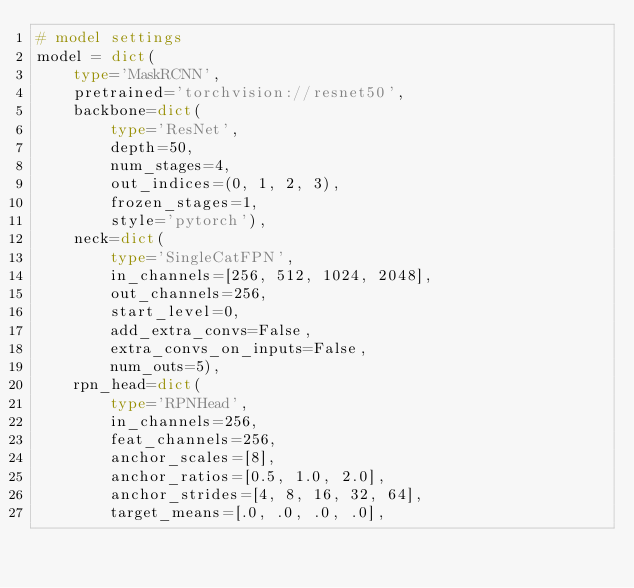<code> <loc_0><loc_0><loc_500><loc_500><_Python_># model settings
model = dict(
    type='MaskRCNN',
    pretrained='torchvision://resnet50',
    backbone=dict(
        type='ResNet',
        depth=50,
        num_stages=4,
        out_indices=(0, 1, 2, 3),
        frozen_stages=1,
        style='pytorch'),
    neck=dict(
        type='SingleCatFPN',
        in_channels=[256, 512, 1024, 2048],
        out_channels=256,
        start_level=0,
        add_extra_convs=False,
        extra_convs_on_inputs=False,
        num_outs=5),
    rpn_head=dict(
        type='RPNHead',
        in_channels=256,
        feat_channels=256,
        anchor_scales=[8],
        anchor_ratios=[0.5, 1.0, 2.0],
        anchor_strides=[4, 8, 16, 32, 64],
        target_means=[.0, .0, .0, .0],</code> 